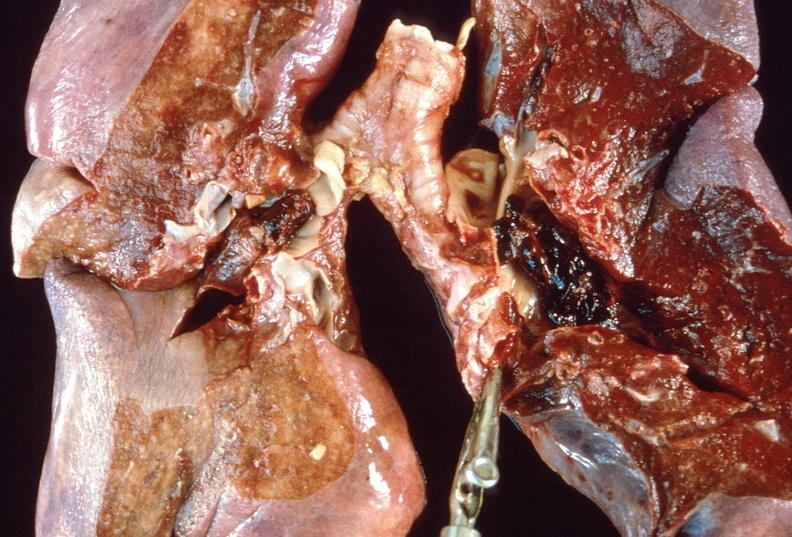what is present?
Answer the question using a single word or phrase. Respiratory 